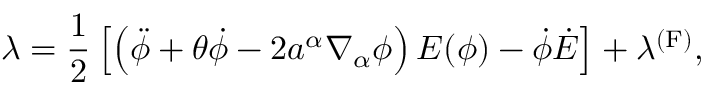Convert formula to latex. <formula><loc_0><loc_0><loc_500><loc_500>\lambda = \frac { 1 } { 2 } \left [ \left ( \ddot { \phi } + \theta \dot { \phi } - 2 a ^ { \alpha } \nabla _ { \alpha } \phi \right ) E ( \phi ) - \dot { \phi } \dot { E } \right ] + \lambda ^ { ( F ) } ,</formula> 